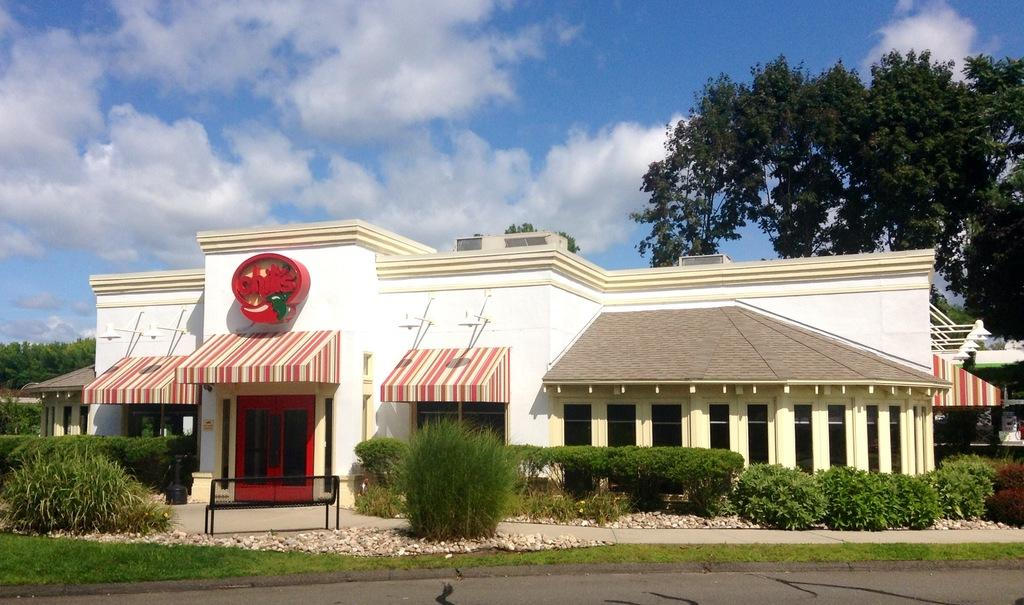<image>
Provide a brief description of the given image. An exterior shot of a Chili's restaurant with stripped awnings.. 